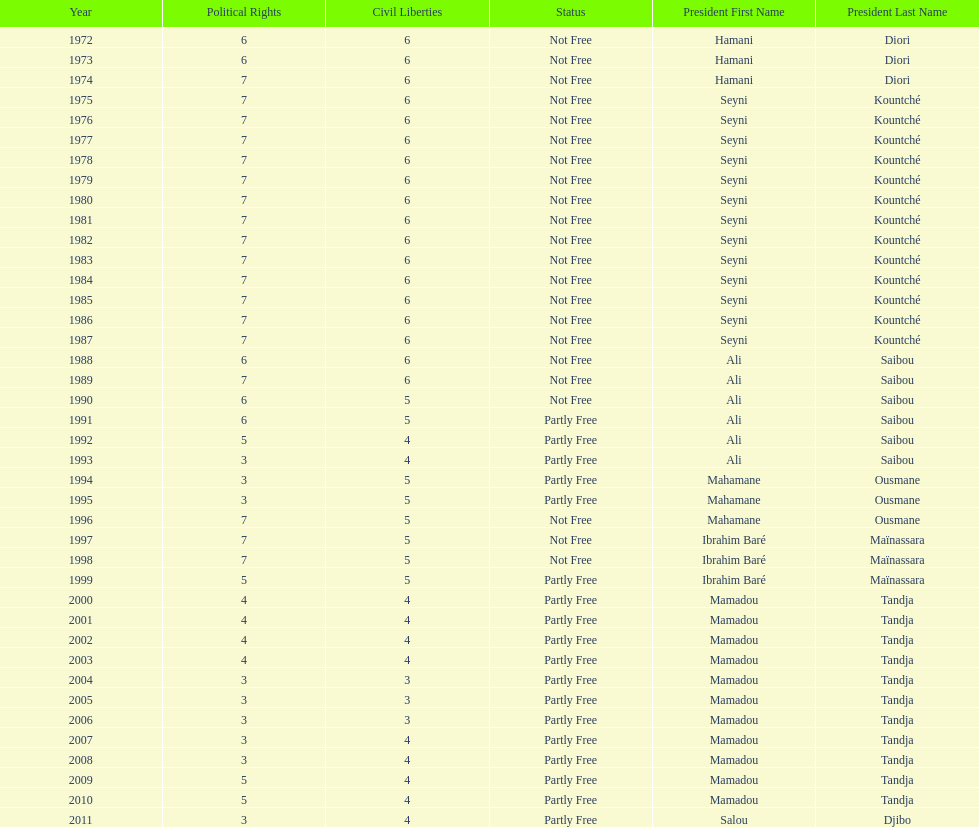How many years was it before the first partly free status? 18. 